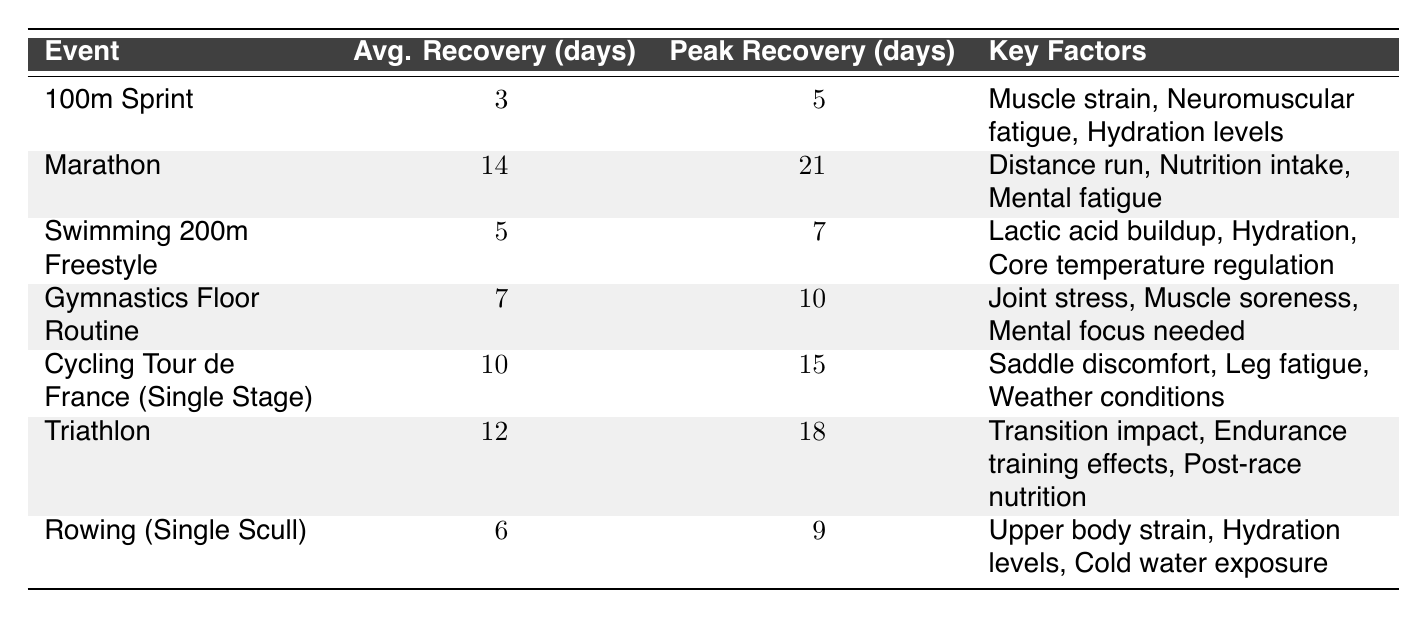What is the average recovery time for the Marathon event? The table lists an average recovery time of 14 days for the Marathon event.
Answer: 14 days Which event has the shortest peak recovery time? According to the table, the 100m Sprint has the shortest peak recovery time of 5 days.
Answer: 5 days What are the factors affecting recovery for the Swimming 200m Freestyle? The table states that factors include lactic acid buildup, hydration, and core temperature regulation for the Swimming 200m Freestyle event.
Answer: Lactic acid buildup, hydration, core temperature regulation How many more days does the Marathon's peak recovery time exceed that of the 100m Sprint? The peak recovery time for the Marathon is 21 days and for the 100m Sprint it is 5 days. The difference is 21 - 5 = 16 days.
Answer: 16 days Is it true that the average recovery time for Triathlon is greater than 10 days? Yes, the average recovery time for Triathlon is 12 days, which is greater than 10 days.
Answer: Yes Which event has an average recovery time greater than 6 days but less than 14 days? The Gymnastics Floor Routine has an average recovery time of 7 days, and the Cycling Tour de France (Single Stage) has 10 days, both of which fit the criteria between 6 and 14 days.
Answer: Gymnastics Floor Routine, Cycling Tour de France (Single Stage) What is the average recovery time across all events listed? To find the average recovery time, sum the average recovery times: (3 + 14 + 5 + 7 + 10 + 12 + 6) = 57 days. There are 7 events; thus, the average is 57 / 7 = approximately 8.14 days.
Answer: Approximately 8.14 days Which event requires the longest peak recovery time? The table indicates that the Marathon has the longest peak recovery time of 21 days.
Answer: 21 days How does the factor of hydration levels affect recovery in both the 100m Sprint and Rowing (Single Scull)? Hydration levels are noted as affecting recovery in both events, indicating that maintaining proper hydration is important for recovery in both the 100m Sprint and Rowing (Single Scull).
Answer: Affects recovery in both events What is the difference in average recovery time between the Swimming 200m Freestyle and the Rowing (Single Scull)? The average recovery time for Swimming 200m Freestyle is 5 days, and for Rowing (Single Scull) it is 6 days. The difference is 6 - 5 = 1 day.
Answer: 1 day 